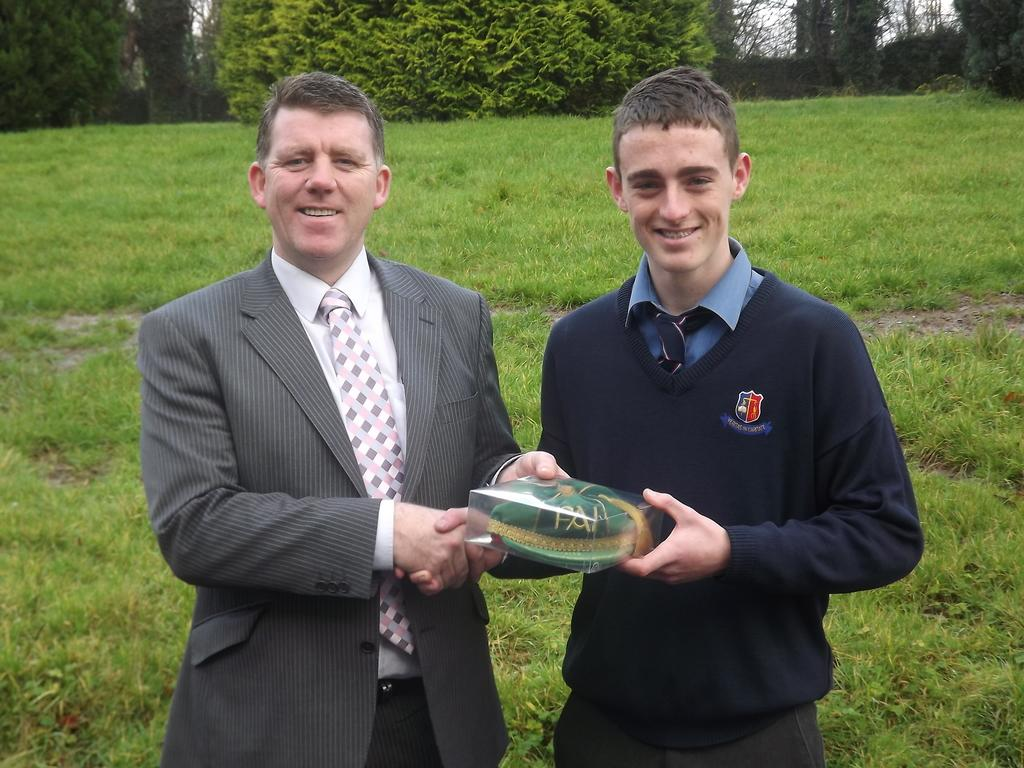How many people are in the image? There are two persons in the image. What are the persons doing in the image? The persons are standing and smiling. What are the persons holding in the image? The persons are holding an object. What can be seen in the background of the image? There are trees and grass visible in the background of the image. What type of coil can be seen in the image? There is no coil present in the image. What is the persons using the hammer for in the image? There is no hammer present in the image, so it cannot be determined what the persons might be using it for. 